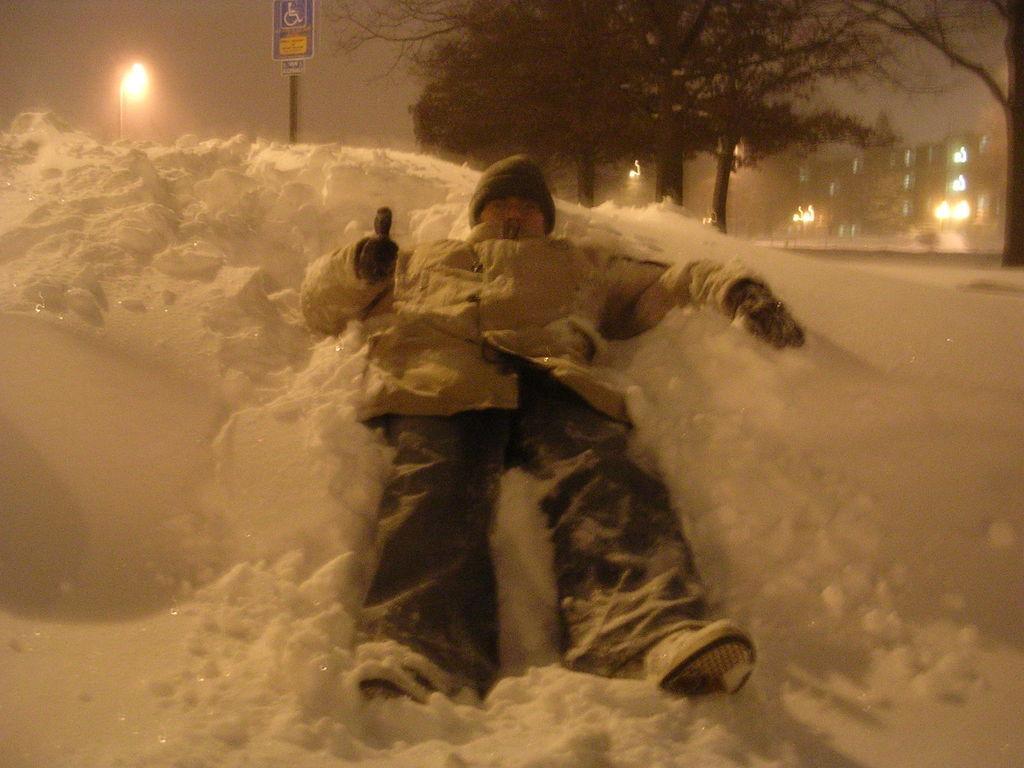How would you summarize this image in a sentence or two? In this picture there is a man who is wearing cap, goggle, gloves, jacket and shoes. He is lying on the snow. In the top left I can see the street light and sign board. At the top I can see many trees. In the background I can see the buildings, street lights and road. In the top right I can see the sky and clouds. 